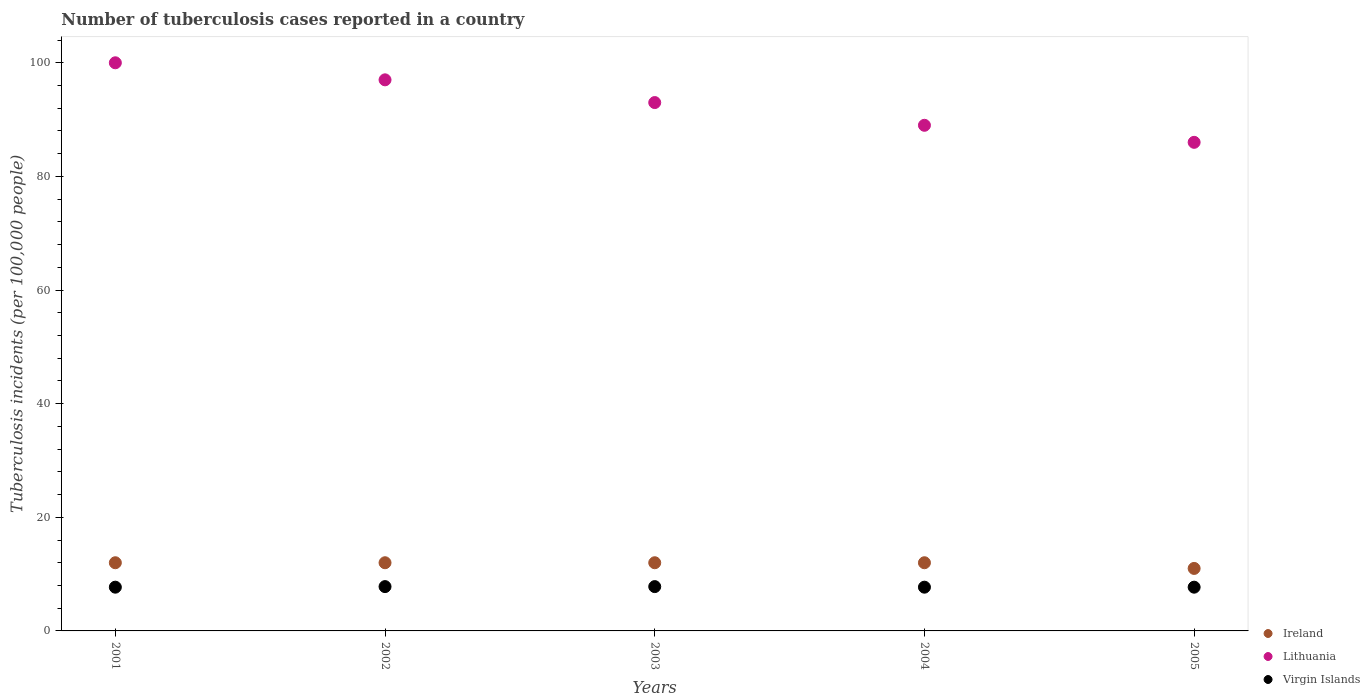Is the number of dotlines equal to the number of legend labels?
Your answer should be compact. Yes. What is the number of tuberculosis cases reported in in Ireland in 2005?
Your response must be concise. 11. Across all years, what is the maximum number of tuberculosis cases reported in in Lithuania?
Your answer should be very brief. 100. Across all years, what is the minimum number of tuberculosis cases reported in in Lithuania?
Offer a terse response. 86. What is the total number of tuberculosis cases reported in in Virgin Islands in the graph?
Keep it short and to the point. 38.7. What is the difference between the number of tuberculosis cases reported in in Ireland in 2001 and that in 2003?
Provide a short and direct response. 0. What is the difference between the number of tuberculosis cases reported in in Ireland in 2002 and the number of tuberculosis cases reported in in Virgin Islands in 2001?
Your response must be concise. 4.3. In the year 2004, what is the difference between the number of tuberculosis cases reported in in Virgin Islands and number of tuberculosis cases reported in in Lithuania?
Offer a very short reply. -81.3. What is the ratio of the number of tuberculosis cases reported in in Ireland in 2002 to that in 2004?
Your answer should be very brief. 1. Is the difference between the number of tuberculosis cases reported in in Virgin Islands in 2001 and 2005 greater than the difference between the number of tuberculosis cases reported in in Lithuania in 2001 and 2005?
Offer a terse response. No. What is the difference between the highest and the second highest number of tuberculosis cases reported in in Ireland?
Keep it short and to the point. 0. What is the difference between the highest and the lowest number of tuberculosis cases reported in in Virgin Islands?
Ensure brevity in your answer.  0.1. In how many years, is the number of tuberculosis cases reported in in Virgin Islands greater than the average number of tuberculosis cases reported in in Virgin Islands taken over all years?
Keep it short and to the point. 2. Is the sum of the number of tuberculosis cases reported in in Ireland in 2002 and 2005 greater than the maximum number of tuberculosis cases reported in in Lithuania across all years?
Provide a short and direct response. No. Is it the case that in every year, the sum of the number of tuberculosis cases reported in in Virgin Islands and number of tuberculosis cases reported in in Lithuania  is greater than the number of tuberculosis cases reported in in Ireland?
Your answer should be compact. Yes. Is the number of tuberculosis cases reported in in Ireland strictly less than the number of tuberculosis cases reported in in Lithuania over the years?
Ensure brevity in your answer.  Yes. How many dotlines are there?
Provide a short and direct response. 3. How many years are there in the graph?
Provide a short and direct response. 5. Are the values on the major ticks of Y-axis written in scientific E-notation?
Make the answer very short. No. How many legend labels are there?
Provide a succinct answer. 3. What is the title of the graph?
Your answer should be compact. Number of tuberculosis cases reported in a country. What is the label or title of the Y-axis?
Offer a very short reply. Tuberculosis incidents (per 100,0 people). What is the Tuberculosis incidents (per 100,000 people) in Lithuania in 2002?
Give a very brief answer. 97. What is the Tuberculosis incidents (per 100,000 people) of Virgin Islands in 2002?
Give a very brief answer. 7.8. What is the Tuberculosis incidents (per 100,000 people) in Lithuania in 2003?
Your answer should be compact. 93. What is the Tuberculosis incidents (per 100,000 people) in Virgin Islands in 2003?
Ensure brevity in your answer.  7.8. What is the Tuberculosis incidents (per 100,000 people) of Lithuania in 2004?
Your answer should be very brief. 89. What is the Tuberculosis incidents (per 100,000 people) of Ireland in 2005?
Ensure brevity in your answer.  11. What is the Tuberculosis incidents (per 100,000 people) of Lithuania in 2005?
Make the answer very short. 86. What is the Tuberculosis incidents (per 100,000 people) in Virgin Islands in 2005?
Your answer should be compact. 7.7. Across all years, what is the maximum Tuberculosis incidents (per 100,000 people) in Ireland?
Your answer should be compact. 12. Across all years, what is the maximum Tuberculosis incidents (per 100,000 people) in Lithuania?
Your response must be concise. 100. What is the total Tuberculosis incidents (per 100,000 people) in Ireland in the graph?
Offer a terse response. 59. What is the total Tuberculosis incidents (per 100,000 people) in Lithuania in the graph?
Offer a very short reply. 465. What is the total Tuberculosis incidents (per 100,000 people) in Virgin Islands in the graph?
Ensure brevity in your answer.  38.7. What is the difference between the Tuberculosis incidents (per 100,000 people) of Ireland in 2001 and that in 2002?
Your answer should be compact. 0. What is the difference between the Tuberculosis incidents (per 100,000 people) in Lithuania in 2001 and that in 2002?
Make the answer very short. 3. What is the difference between the Tuberculosis incidents (per 100,000 people) in Ireland in 2001 and that in 2003?
Make the answer very short. 0. What is the difference between the Tuberculosis incidents (per 100,000 people) in Virgin Islands in 2001 and that in 2003?
Your answer should be compact. -0.1. What is the difference between the Tuberculosis incidents (per 100,000 people) in Ireland in 2001 and that in 2004?
Ensure brevity in your answer.  0. What is the difference between the Tuberculosis incidents (per 100,000 people) in Lithuania in 2001 and that in 2004?
Your response must be concise. 11. What is the difference between the Tuberculosis incidents (per 100,000 people) in Virgin Islands in 2001 and that in 2004?
Your answer should be compact. 0. What is the difference between the Tuberculosis incidents (per 100,000 people) of Virgin Islands in 2001 and that in 2005?
Provide a succinct answer. 0. What is the difference between the Tuberculosis incidents (per 100,000 people) of Virgin Islands in 2002 and that in 2003?
Provide a short and direct response. 0. What is the difference between the Tuberculosis incidents (per 100,000 people) of Lithuania in 2002 and that in 2004?
Give a very brief answer. 8. What is the difference between the Tuberculosis incidents (per 100,000 people) in Ireland in 2002 and that in 2005?
Make the answer very short. 1. What is the difference between the Tuberculosis incidents (per 100,000 people) in Virgin Islands in 2002 and that in 2005?
Your answer should be compact. 0.1. What is the difference between the Tuberculosis incidents (per 100,000 people) of Lithuania in 2003 and that in 2004?
Give a very brief answer. 4. What is the difference between the Tuberculosis incidents (per 100,000 people) in Ireland in 2003 and that in 2005?
Make the answer very short. 1. What is the difference between the Tuberculosis incidents (per 100,000 people) of Lithuania in 2003 and that in 2005?
Give a very brief answer. 7. What is the difference between the Tuberculosis incidents (per 100,000 people) in Ireland in 2004 and that in 2005?
Ensure brevity in your answer.  1. What is the difference between the Tuberculosis incidents (per 100,000 people) of Lithuania in 2004 and that in 2005?
Provide a succinct answer. 3. What is the difference between the Tuberculosis incidents (per 100,000 people) in Ireland in 2001 and the Tuberculosis incidents (per 100,000 people) in Lithuania in 2002?
Your answer should be very brief. -85. What is the difference between the Tuberculosis incidents (per 100,000 people) of Ireland in 2001 and the Tuberculosis incidents (per 100,000 people) of Virgin Islands in 2002?
Keep it short and to the point. 4.2. What is the difference between the Tuberculosis incidents (per 100,000 people) in Lithuania in 2001 and the Tuberculosis incidents (per 100,000 people) in Virgin Islands in 2002?
Give a very brief answer. 92.2. What is the difference between the Tuberculosis incidents (per 100,000 people) of Ireland in 2001 and the Tuberculosis incidents (per 100,000 people) of Lithuania in 2003?
Your response must be concise. -81. What is the difference between the Tuberculosis incidents (per 100,000 people) in Ireland in 2001 and the Tuberculosis incidents (per 100,000 people) in Virgin Islands in 2003?
Make the answer very short. 4.2. What is the difference between the Tuberculosis incidents (per 100,000 people) in Lithuania in 2001 and the Tuberculosis incidents (per 100,000 people) in Virgin Islands in 2003?
Provide a succinct answer. 92.2. What is the difference between the Tuberculosis incidents (per 100,000 people) of Ireland in 2001 and the Tuberculosis incidents (per 100,000 people) of Lithuania in 2004?
Keep it short and to the point. -77. What is the difference between the Tuberculosis incidents (per 100,000 people) in Lithuania in 2001 and the Tuberculosis incidents (per 100,000 people) in Virgin Islands in 2004?
Give a very brief answer. 92.3. What is the difference between the Tuberculosis incidents (per 100,000 people) of Ireland in 2001 and the Tuberculosis incidents (per 100,000 people) of Lithuania in 2005?
Make the answer very short. -74. What is the difference between the Tuberculosis incidents (per 100,000 people) in Lithuania in 2001 and the Tuberculosis incidents (per 100,000 people) in Virgin Islands in 2005?
Offer a terse response. 92.3. What is the difference between the Tuberculosis incidents (per 100,000 people) of Ireland in 2002 and the Tuberculosis incidents (per 100,000 people) of Lithuania in 2003?
Make the answer very short. -81. What is the difference between the Tuberculosis incidents (per 100,000 people) in Lithuania in 2002 and the Tuberculosis incidents (per 100,000 people) in Virgin Islands in 2003?
Your response must be concise. 89.2. What is the difference between the Tuberculosis incidents (per 100,000 people) of Ireland in 2002 and the Tuberculosis incidents (per 100,000 people) of Lithuania in 2004?
Provide a short and direct response. -77. What is the difference between the Tuberculosis incidents (per 100,000 people) in Ireland in 2002 and the Tuberculosis incidents (per 100,000 people) in Virgin Islands in 2004?
Keep it short and to the point. 4.3. What is the difference between the Tuberculosis incidents (per 100,000 people) in Lithuania in 2002 and the Tuberculosis incidents (per 100,000 people) in Virgin Islands in 2004?
Offer a terse response. 89.3. What is the difference between the Tuberculosis incidents (per 100,000 people) of Ireland in 2002 and the Tuberculosis incidents (per 100,000 people) of Lithuania in 2005?
Your answer should be very brief. -74. What is the difference between the Tuberculosis incidents (per 100,000 people) in Ireland in 2002 and the Tuberculosis incidents (per 100,000 people) in Virgin Islands in 2005?
Provide a short and direct response. 4.3. What is the difference between the Tuberculosis incidents (per 100,000 people) of Lithuania in 2002 and the Tuberculosis incidents (per 100,000 people) of Virgin Islands in 2005?
Your answer should be very brief. 89.3. What is the difference between the Tuberculosis incidents (per 100,000 people) of Ireland in 2003 and the Tuberculosis incidents (per 100,000 people) of Lithuania in 2004?
Offer a very short reply. -77. What is the difference between the Tuberculosis incidents (per 100,000 people) in Lithuania in 2003 and the Tuberculosis incidents (per 100,000 people) in Virgin Islands in 2004?
Keep it short and to the point. 85.3. What is the difference between the Tuberculosis incidents (per 100,000 people) of Ireland in 2003 and the Tuberculosis incidents (per 100,000 people) of Lithuania in 2005?
Provide a short and direct response. -74. What is the difference between the Tuberculosis incidents (per 100,000 people) of Lithuania in 2003 and the Tuberculosis incidents (per 100,000 people) of Virgin Islands in 2005?
Your answer should be compact. 85.3. What is the difference between the Tuberculosis incidents (per 100,000 people) of Ireland in 2004 and the Tuberculosis incidents (per 100,000 people) of Lithuania in 2005?
Your answer should be compact. -74. What is the difference between the Tuberculosis incidents (per 100,000 people) in Lithuania in 2004 and the Tuberculosis incidents (per 100,000 people) in Virgin Islands in 2005?
Your answer should be compact. 81.3. What is the average Tuberculosis incidents (per 100,000 people) in Ireland per year?
Make the answer very short. 11.8. What is the average Tuberculosis incidents (per 100,000 people) of Lithuania per year?
Provide a short and direct response. 93. What is the average Tuberculosis incidents (per 100,000 people) in Virgin Islands per year?
Your response must be concise. 7.74. In the year 2001, what is the difference between the Tuberculosis incidents (per 100,000 people) of Ireland and Tuberculosis incidents (per 100,000 people) of Lithuania?
Provide a succinct answer. -88. In the year 2001, what is the difference between the Tuberculosis incidents (per 100,000 people) of Ireland and Tuberculosis incidents (per 100,000 people) of Virgin Islands?
Offer a terse response. 4.3. In the year 2001, what is the difference between the Tuberculosis incidents (per 100,000 people) in Lithuania and Tuberculosis incidents (per 100,000 people) in Virgin Islands?
Your response must be concise. 92.3. In the year 2002, what is the difference between the Tuberculosis incidents (per 100,000 people) of Ireland and Tuberculosis incidents (per 100,000 people) of Lithuania?
Your response must be concise. -85. In the year 2002, what is the difference between the Tuberculosis incidents (per 100,000 people) in Ireland and Tuberculosis incidents (per 100,000 people) in Virgin Islands?
Ensure brevity in your answer.  4.2. In the year 2002, what is the difference between the Tuberculosis incidents (per 100,000 people) in Lithuania and Tuberculosis incidents (per 100,000 people) in Virgin Islands?
Keep it short and to the point. 89.2. In the year 2003, what is the difference between the Tuberculosis incidents (per 100,000 people) in Ireland and Tuberculosis incidents (per 100,000 people) in Lithuania?
Provide a short and direct response. -81. In the year 2003, what is the difference between the Tuberculosis incidents (per 100,000 people) of Lithuania and Tuberculosis incidents (per 100,000 people) of Virgin Islands?
Keep it short and to the point. 85.2. In the year 2004, what is the difference between the Tuberculosis incidents (per 100,000 people) in Ireland and Tuberculosis incidents (per 100,000 people) in Lithuania?
Ensure brevity in your answer.  -77. In the year 2004, what is the difference between the Tuberculosis incidents (per 100,000 people) of Lithuania and Tuberculosis incidents (per 100,000 people) of Virgin Islands?
Your answer should be compact. 81.3. In the year 2005, what is the difference between the Tuberculosis incidents (per 100,000 people) of Ireland and Tuberculosis incidents (per 100,000 people) of Lithuania?
Offer a very short reply. -75. In the year 2005, what is the difference between the Tuberculosis incidents (per 100,000 people) in Lithuania and Tuberculosis incidents (per 100,000 people) in Virgin Islands?
Ensure brevity in your answer.  78.3. What is the ratio of the Tuberculosis incidents (per 100,000 people) of Ireland in 2001 to that in 2002?
Offer a very short reply. 1. What is the ratio of the Tuberculosis incidents (per 100,000 people) of Lithuania in 2001 to that in 2002?
Offer a very short reply. 1.03. What is the ratio of the Tuberculosis incidents (per 100,000 people) in Virgin Islands in 2001 to that in 2002?
Your response must be concise. 0.99. What is the ratio of the Tuberculosis incidents (per 100,000 people) in Ireland in 2001 to that in 2003?
Provide a short and direct response. 1. What is the ratio of the Tuberculosis incidents (per 100,000 people) of Lithuania in 2001 to that in 2003?
Your answer should be very brief. 1.08. What is the ratio of the Tuberculosis incidents (per 100,000 people) in Virgin Islands in 2001 to that in 2003?
Provide a short and direct response. 0.99. What is the ratio of the Tuberculosis incidents (per 100,000 people) in Lithuania in 2001 to that in 2004?
Your answer should be compact. 1.12. What is the ratio of the Tuberculosis incidents (per 100,000 people) of Virgin Islands in 2001 to that in 2004?
Your answer should be very brief. 1. What is the ratio of the Tuberculosis incidents (per 100,000 people) of Lithuania in 2001 to that in 2005?
Make the answer very short. 1.16. What is the ratio of the Tuberculosis incidents (per 100,000 people) in Virgin Islands in 2001 to that in 2005?
Offer a terse response. 1. What is the ratio of the Tuberculosis incidents (per 100,000 people) in Ireland in 2002 to that in 2003?
Give a very brief answer. 1. What is the ratio of the Tuberculosis incidents (per 100,000 people) in Lithuania in 2002 to that in 2003?
Keep it short and to the point. 1.04. What is the ratio of the Tuberculosis incidents (per 100,000 people) in Virgin Islands in 2002 to that in 2003?
Give a very brief answer. 1. What is the ratio of the Tuberculosis incidents (per 100,000 people) in Ireland in 2002 to that in 2004?
Your response must be concise. 1. What is the ratio of the Tuberculosis incidents (per 100,000 people) in Lithuania in 2002 to that in 2004?
Give a very brief answer. 1.09. What is the ratio of the Tuberculosis incidents (per 100,000 people) of Ireland in 2002 to that in 2005?
Your answer should be compact. 1.09. What is the ratio of the Tuberculosis incidents (per 100,000 people) of Lithuania in 2002 to that in 2005?
Provide a short and direct response. 1.13. What is the ratio of the Tuberculosis incidents (per 100,000 people) of Lithuania in 2003 to that in 2004?
Your response must be concise. 1.04. What is the ratio of the Tuberculosis incidents (per 100,000 people) of Lithuania in 2003 to that in 2005?
Your response must be concise. 1.08. What is the ratio of the Tuberculosis incidents (per 100,000 people) of Virgin Islands in 2003 to that in 2005?
Make the answer very short. 1.01. What is the ratio of the Tuberculosis incidents (per 100,000 people) in Lithuania in 2004 to that in 2005?
Your response must be concise. 1.03. What is the difference between the highest and the second highest Tuberculosis incidents (per 100,000 people) of Ireland?
Provide a succinct answer. 0. What is the difference between the highest and the second highest Tuberculosis incidents (per 100,000 people) of Lithuania?
Your answer should be compact. 3. What is the difference between the highest and the lowest Tuberculosis incidents (per 100,000 people) in Ireland?
Your response must be concise. 1. What is the difference between the highest and the lowest Tuberculosis incidents (per 100,000 people) of Lithuania?
Provide a short and direct response. 14. What is the difference between the highest and the lowest Tuberculosis incidents (per 100,000 people) of Virgin Islands?
Keep it short and to the point. 0.1. 